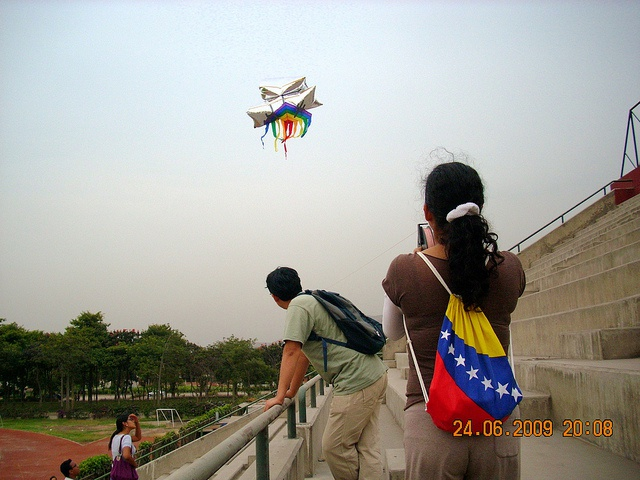Describe the objects in this image and their specific colors. I can see people in darkgray, black, maroon, navy, and gray tones, people in darkgray, black, gray, and olive tones, backpack in darkgray, navy, maroon, darkblue, and brown tones, bench in darkgray, gray, and olive tones, and backpack in darkgray, black, gray, and darkgreen tones in this image. 